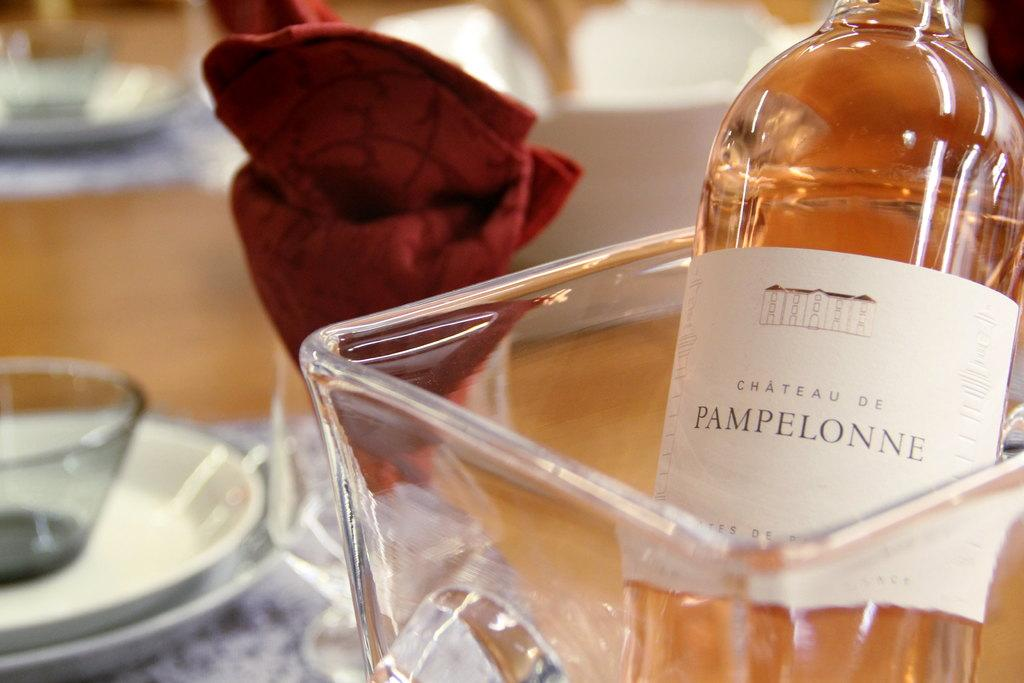<image>
Provide a brief description of the given image. A bottle of Chateau de Pampelonne wine is in a glass wine bucket on a table. 